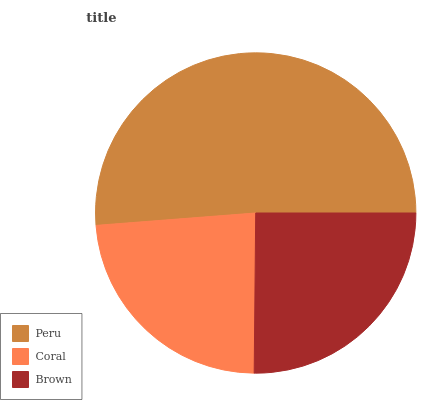Is Coral the minimum?
Answer yes or no. Yes. Is Peru the maximum?
Answer yes or no. Yes. Is Brown the minimum?
Answer yes or no. No. Is Brown the maximum?
Answer yes or no. No. Is Brown greater than Coral?
Answer yes or no. Yes. Is Coral less than Brown?
Answer yes or no. Yes. Is Coral greater than Brown?
Answer yes or no. No. Is Brown less than Coral?
Answer yes or no. No. Is Brown the high median?
Answer yes or no. Yes. Is Brown the low median?
Answer yes or no. Yes. Is Peru the high median?
Answer yes or no. No. Is Peru the low median?
Answer yes or no. No. 